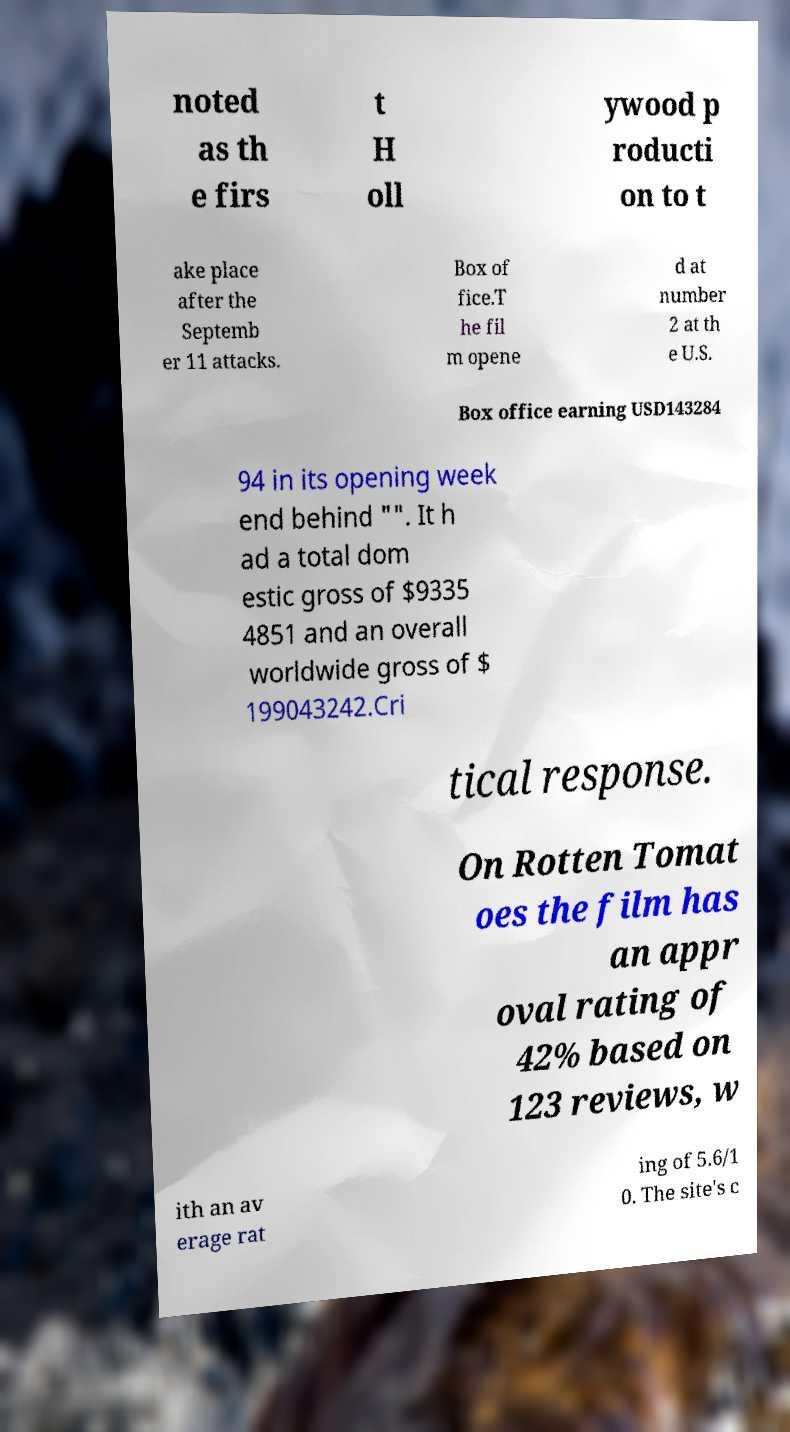For documentation purposes, I need the text within this image transcribed. Could you provide that? noted as th e firs t H oll ywood p roducti on to t ake place after the Septemb er 11 attacks. Box of fice.T he fil m opene d at number 2 at th e U.S. Box office earning USD143284 94 in its opening week end behind "". It h ad a total dom estic gross of $9335 4851 and an overall worldwide gross of $ 199043242.Cri tical response. On Rotten Tomat oes the film has an appr oval rating of 42% based on 123 reviews, w ith an av erage rat ing of 5.6/1 0. The site's c 